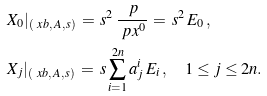Convert formula to latex. <formula><loc_0><loc_0><loc_500><loc_500>& X _ { 0 } | _ { ( \ x b , \, A , \, s ) } \, = \, s ^ { 2 } \, \frac { \ p } { \ p x ^ { 0 } } \, = \, s ^ { 2 } \, E _ { 0 } \, , \\ & X _ { j } | _ { ( \ x b , \, A , \, s ) } \, = \, s \sum _ { i = 1 } ^ { 2 n } a ^ { i } _ { j } \, E _ { i } \, , \quad 1 \leq j \leq 2 n .</formula> 